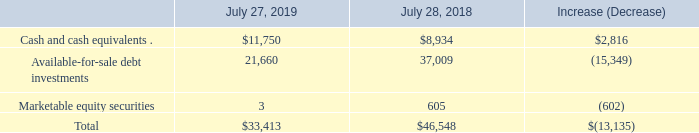Balance Sheet and Cash Flows
Cash and Cash Equivalents and Investments The following table summarizes our cash and cash equivalents and investments (in millions):
The net decrease in cash and cash equivalents and investments from fiscal 2018 to fiscal 2019 was primarily driven by cash returned to shareholders in the form of repurchases of common stock of $20.7 billion under the stock repurchase program and cash dividends of $6.0 billion, net cash paid for acquisitions and divestitures of $2.2 billion, a net decrease in debt of $1.1 billion, and capital expenditures of $0.9 billion. These uses of cash were partially offset by cash provided by operating activities of $15.8 billion and the timing of settlements of investments and other of $2.0 billion.
In addition to cash requirements in the normal course of business, on July 9, 2019 we announced our intent to acquire Acacia Communications, Inc. (“Acacia”) for a purchase consideration of approximately $2.6 billion in cash. Additionally, $0.7 billion of the U.S. transition tax on accumulated earnings for foreign subsidiaries, $6.0 billion of long-term debt and $4.2 billion of commercial paper notes outstanding at July 27, 2019, are payable within the next 12 months from the balance sheet date. See further discussion of liquidity and future payments under “Contractual Obligations” and “Liquidity and Capital Resource Requirements” below.
We maintain an investment portfolio of various holdings, types, and maturities. We classify our investments as short-term investments based on their nature and their availability for use in current operations. We believe the overall credit quality of our portfolio is strong, with our cash equivalents and our available-for-sale debt investment portfolio consisting primarily of high quality investment-grade securities. We believe that our strong cash and cash equivalents and investments position allows us to use our cash resources for strategic investments to gain access to new technologies, for acquisitions, for customer financing activities, for working capital needs, and for the repurchase of shares of common stock and payment of dividends as discussed below.
Which years does the table provide information for  cash and cash equivalents and investments? 2019, 2018. How are the company's investments classified as short-term? Based on their nature and their availability for use in current operations. What was the increase (decrease) in available-for-sale debt investments?
Answer scale should be: million. (15,349). What was the difference between cash and cash equivalents and Available-for-sale debt investments in 2019?
Answer scale should be: million. 21,660-11,750
Answer: 9910. How many years did Marketable equity securities exceed $500 million?  2018
Answer: 1. What was the percentage change in the total between 2018 and 2019?
Answer scale should be: percent. (33,413-46,548)/46,548
Answer: -28.22. 